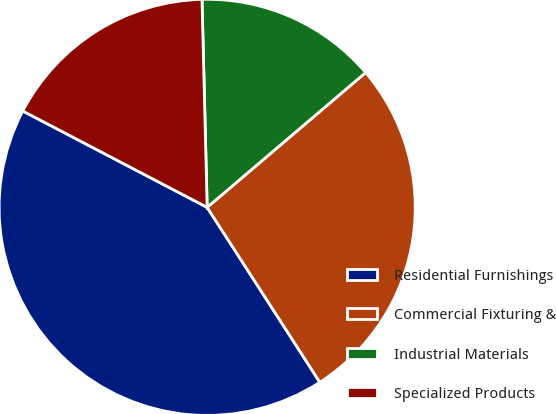Convert chart to OTSL. <chart><loc_0><loc_0><loc_500><loc_500><pie_chart><fcel>Residential Furnishings<fcel>Commercial Fixturing &<fcel>Industrial Materials<fcel>Specialized Products<nl><fcel>41.78%<fcel>27.11%<fcel>14.18%<fcel>16.94%<nl></chart> 